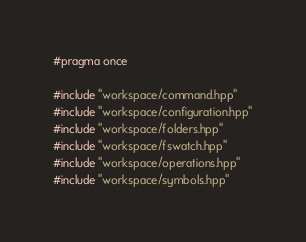Convert code to text. <code><loc_0><loc_0><loc_500><loc_500><_C++_>#pragma once

#include "workspace/command.hpp"
#include "workspace/configuration.hpp"
#include "workspace/folders.hpp"
#include "workspace/fswatch.hpp"
#include "workspace/operations.hpp"
#include "workspace/symbols.hpp"</code> 